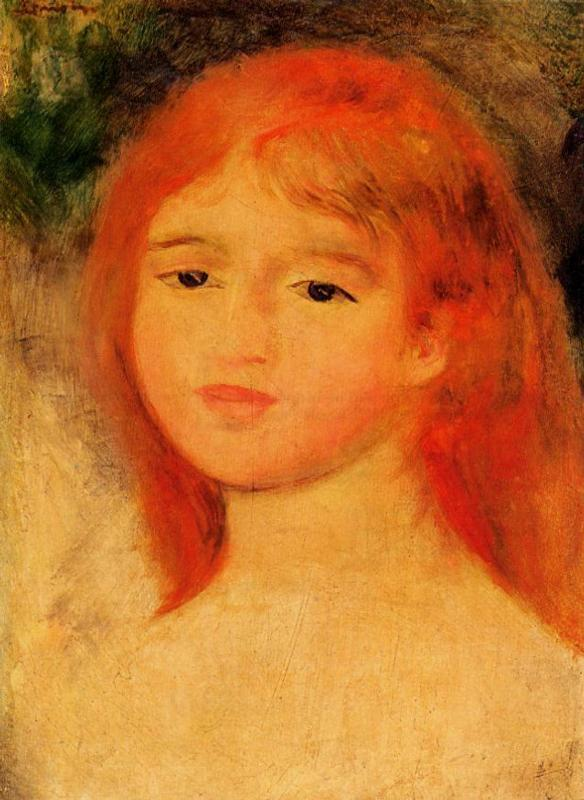Can you describe the emotional impact this portrait might have on a viewer and why? This portrait might evoke a sense of quiet introspection or gentle melancholy due to the soft, swirling brushstrokes and the contemplative gaze of the young girl. The choice of warm colors contributes to a feeling of intimacy, drawing viewers into a personal, reflective moment captured by the artist. The impressionist style, emphasizing fleeting impressions over detailed accuracy, often allows viewers to engage more deeply with the emotional aspects of the scene, making this artwork particularly evocative. 